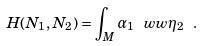<formula> <loc_0><loc_0><loc_500><loc_500>H ( N _ { 1 } , N _ { 2 } ) = \int _ { M } \alpha _ { 1 } \ w w \eta _ { 2 } \ .</formula> 